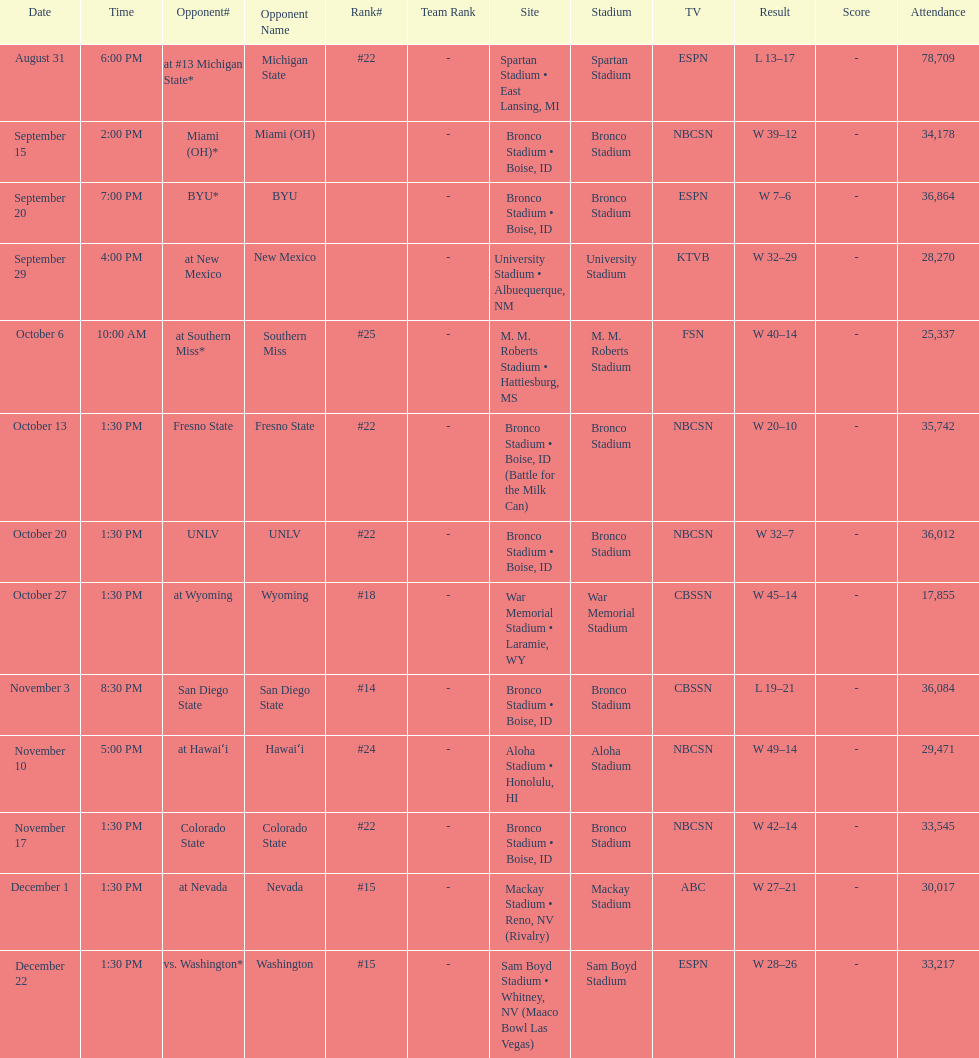What is the total number of games played at bronco stadium? 6. 